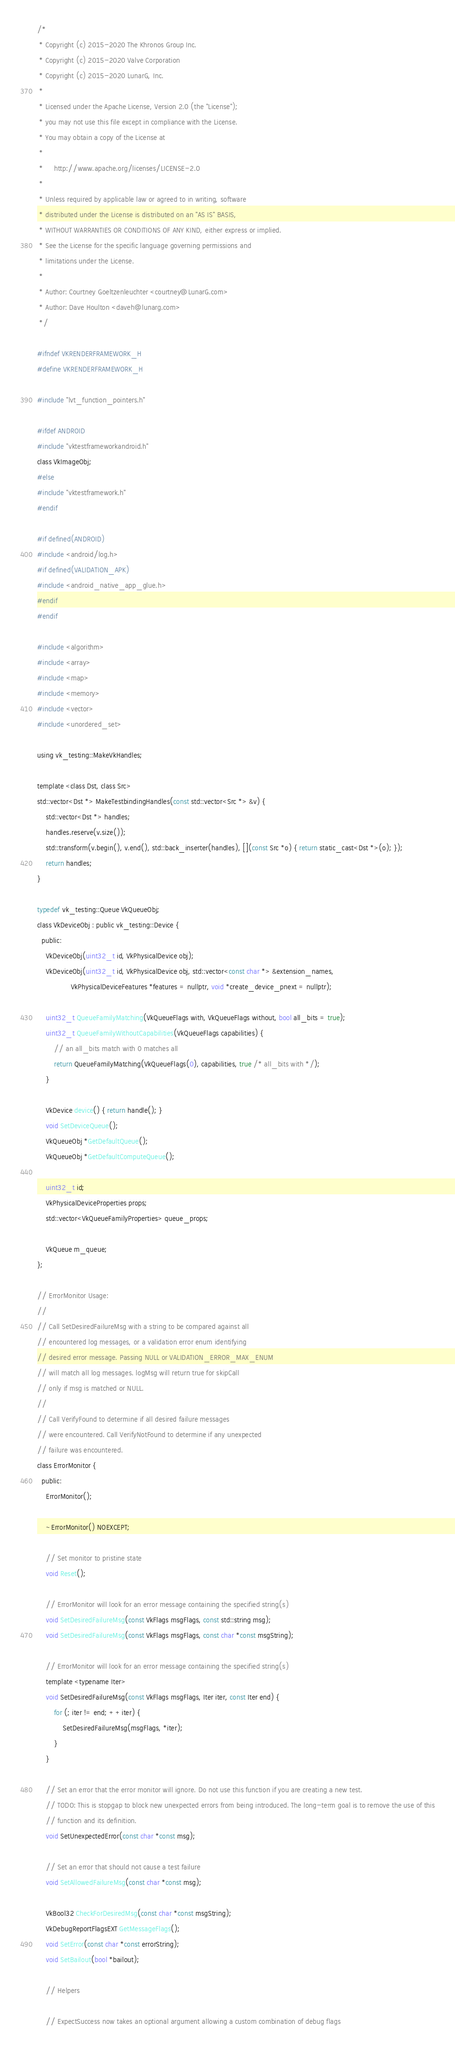Convert code to text. <code><loc_0><loc_0><loc_500><loc_500><_C_>/*
 * Copyright (c) 2015-2020 The Khronos Group Inc.
 * Copyright (c) 2015-2020 Valve Corporation
 * Copyright (c) 2015-2020 LunarG, Inc.
 *
 * Licensed under the Apache License, Version 2.0 (the "License");
 * you may not use this file except in compliance with the License.
 * You may obtain a copy of the License at
 *
 *     http://www.apache.org/licenses/LICENSE-2.0
 *
 * Unless required by applicable law or agreed to in writing, software
 * distributed under the License is distributed on an "AS IS" BASIS,
 * WITHOUT WARRANTIES OR CONDITIONS OF ANY KIND, either express or implied.
 * See the License for the specific language governing permissions and
 * limitations under the License.
 *
 * Author: Courtney Goeltzenleuchter <courtney@LunarG.com>
 * Author: Dave Houlton <daveh@lunarg.com>
 */

#ifndef VKRENDERFRAMEWORK_H
#define VKRENDERFRAMEWORK_H

#include "lvt_function_pointers.h"

#ifdef ANDROID
#include "vktestframeworkandroid.h"
class VkImageObj;
#else
#include "vktestframework.h"
#endif

#if defined(ANDROID)
#include <android/log.h>
#if defined(VALIDATION_APK)
#include <android_native_app_glue.h>
#endif
#endif

#include <algorithm>
#include <array>
#include <map>
#include <memory>
#include <vector>
#include <unordered_set>

using vk_testing::MakeVkHandles;

template <class Dst, class Src>
std::vector<Dst *> MakeTestbindingHandles(const std::vector<Src *> &v) {
    std::vector<Dst *> handles;
    handles.reserve(v.size());
    std::transform(v.begin(), v.end(), std::back_inserter(handles), [](const Src *o) { return static_cast<Dst *>(o); });
    return handles;
}

typedef vk_testing::Queue VkQueueObj;
class VkDeviceObj : public vk_testing::Device {
  public:
    VkDeviceObj(uint32_t id, VkPhysicalDevice obj);
    VkDeviceObj(uint32_t id, VkPhysicalDevice obj, std::vector<const char *> &extension_names,
                VkPhysicalDeviceFeatures *features = nullptr, void *create_device_pnext = nullptr);

    uint32_t QueueFamilyMatching(VkQueueFlags with, VkQueueFlags without, bool all_bits = true);
    uint32_t QueueFamilyWithoutCapabilities(VkQueueFlags capabilities) {
        // an all_bits match with 0 matches all
        return QueueFamilyMatching(VkQueueFlags(0), capabilities, true /* all_bits with */);
    }

    VkDevice device() { return handle(); }
    void SetDeviceQueue();
    VkQueueObj *GetDefaultQueue();
    VkQueueObj *GetDefaultComputeQueue();

    uint32_t id;
    VkPhysicalDeviceProperties props;
    std::vector<VkQueueFamilyProperties> queue_props;

    VkQueue m_queue;
};

// ErrorMonitor Usage:
//
// Call SetDesiredFailureMsg with a string to be compared against all
// encountered log messages, or a validation error enum identifying
// desired error message. Passing NULL or VALIDATION_ERROR_MAX_ENUM
// will match all log messages. logMsg will return true for skipCall
// only if msg is matched or NULL.
//
// Call VerifyFound to determine if all desired failure messages
// were encountered. Call VerifyNotFound to determine if any unexpected
// failure was encountered.
class ErrorMonitor {
  public:
    ErrorMonitor();

    ~ErrorMonitor() NOEXCEPT;

    // Set monitor to pristine state
    void Reset();

    // ErrorMonitor will look for an error message containing the specified string(s)
    void SetDesiredFailureMsg(const VkFlags msgFlags, const std::string msg);
    void SetDesiredFailureMsg(const VkFlags msgFlags, const char *const msgString);

    // ErrorMonitor will look for an error message containing the specified string(s)
    template <typename Iter>
    void SetDesiredFailureMsg(const VkFlags msgFlags, Iter iter, const Iter end) {
        for (; iter != end; ++iter) {
            SetDesiredFailureMsg(msgFlags, *iter);
        }
    }

    // Set an error that the error monitor will ignore. Do not use this function if you are creating a new test.
    // TODO: This is stopgap to block new unexpected errors from being introduced. The long-term goal is to remove the use of this
    // function and its definition.
    void SetUnexpectedError(const char *const msg);

    // Set an error that should not cause a test failure
    void SetAllowedFailureMsg(const char *const msg);

    VkBool32 CheckForDesiredMsg(const char *const msgString);
    VkDebugReportFlagsEXT GetMessageFlags();
    void SetError(const char *const errorString);
    void SetBailout(bool *bailout);

    // Helpers

    // ExpectSuccess now takes an optional argument allowing a custom combination of debug flags</code> 